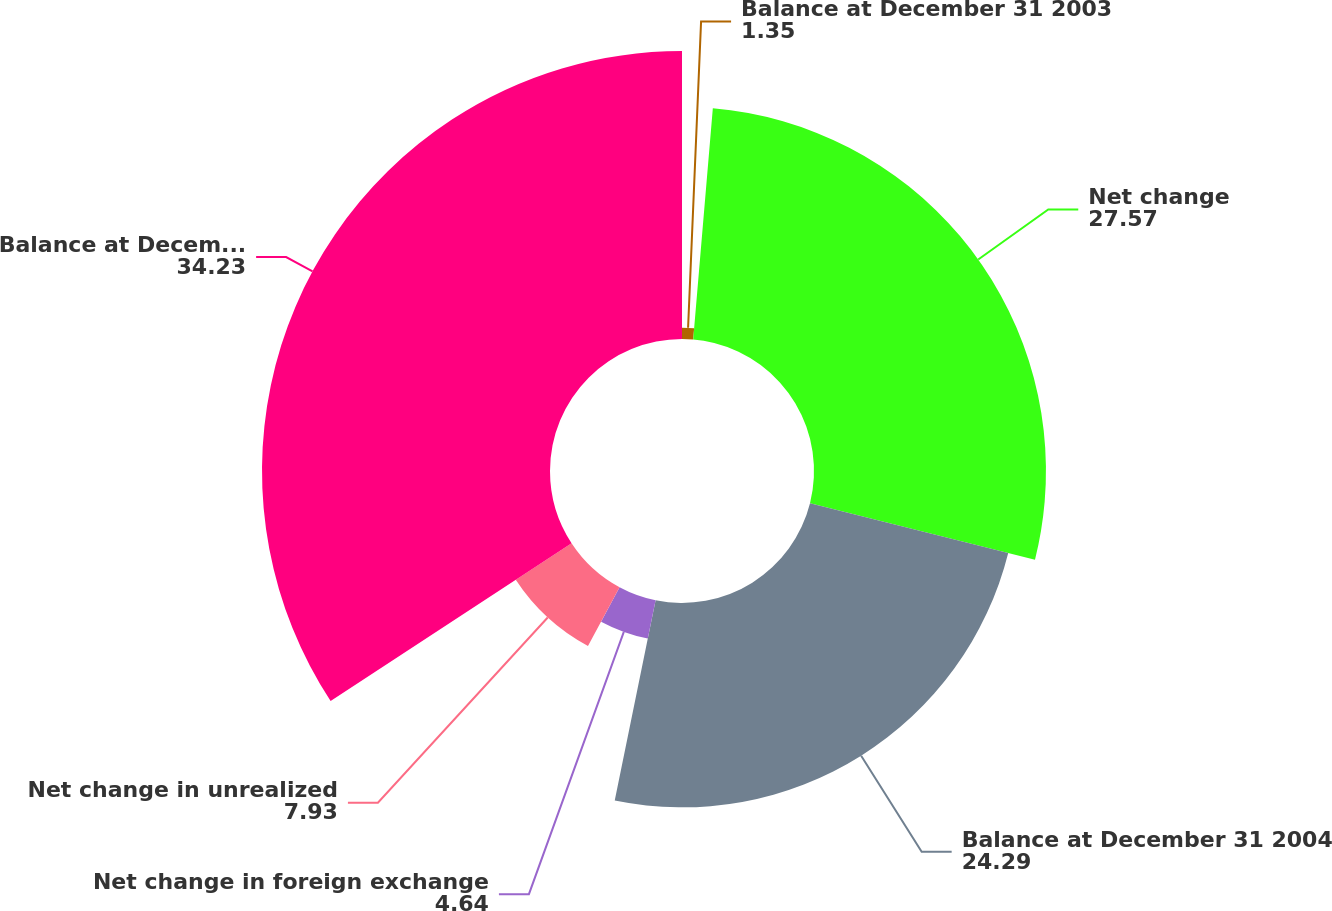Convert chart. <chart><loc_0><loc_0><loc_500><loc_500><pie_chart><fcel>Balance at December 31 2003<fcel>Net change<fcel>Balance at December 31 2004<fcel>Net change in foreign exchange<fcel>Net change in unrealized<fcel>Balance at December 31 2005<nl><fcel>1.35%<fcel>27.57%<fcel>24.29%<fcel>4.64%<fcel>7.93%<fcel>34.23%<nl></chart> 